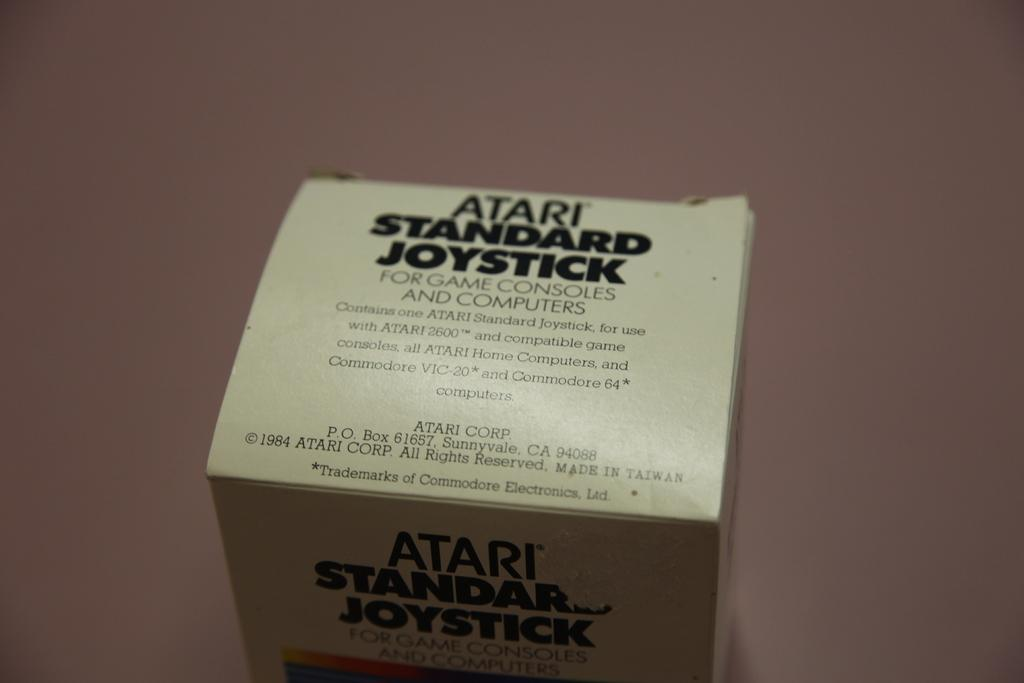<image>
Present a compact description of the photo's key features. The box for an atari standard joystick on a table 